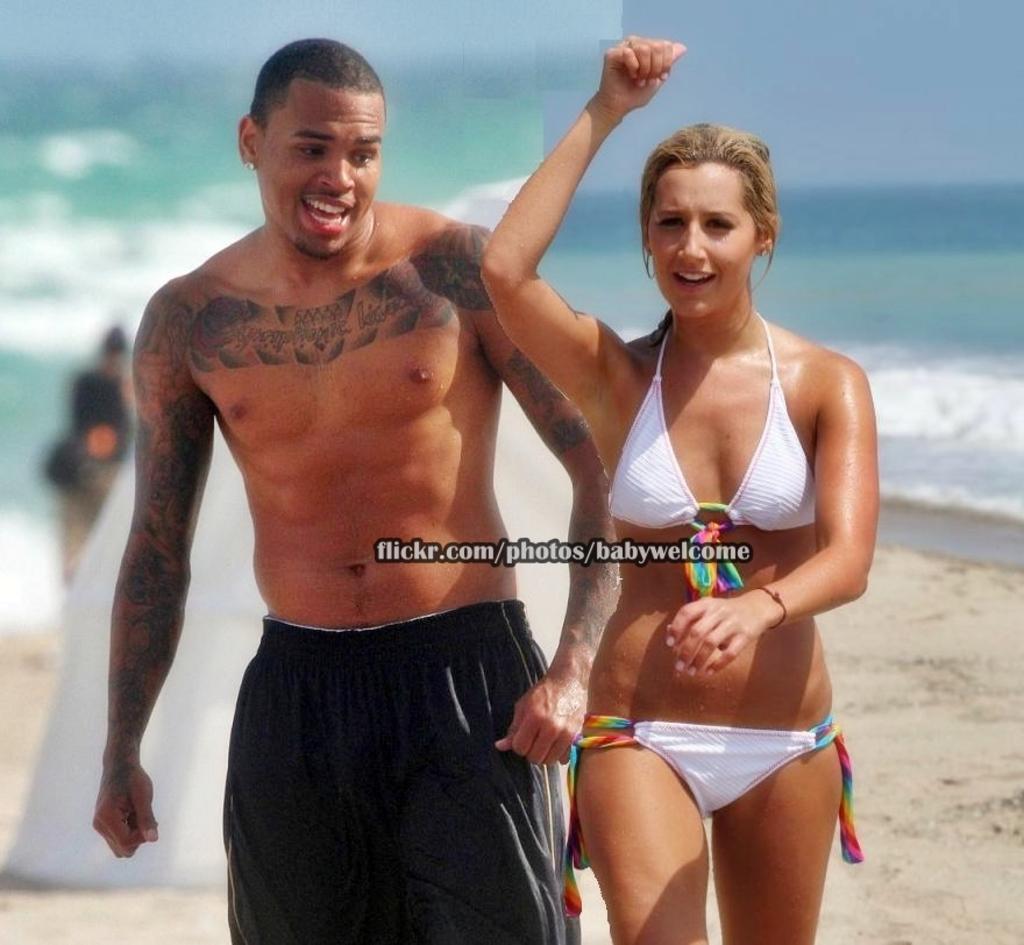Can you describe this image briefly? In the center of the image, we can see a man and a lady and a lady and we can see some text. In the background, there is water and sand and another person. 